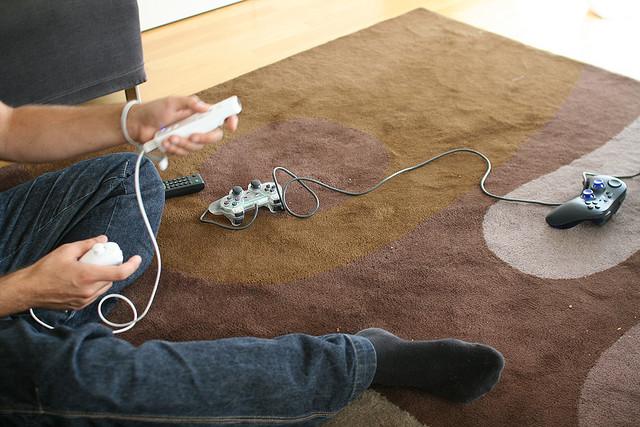What is on the floor?
Be succinct. Controllers. What type of game controller is the person holding?
Short answer required. Wii. What gaming system is he playing with?
Give a very brief answer. Wii. 